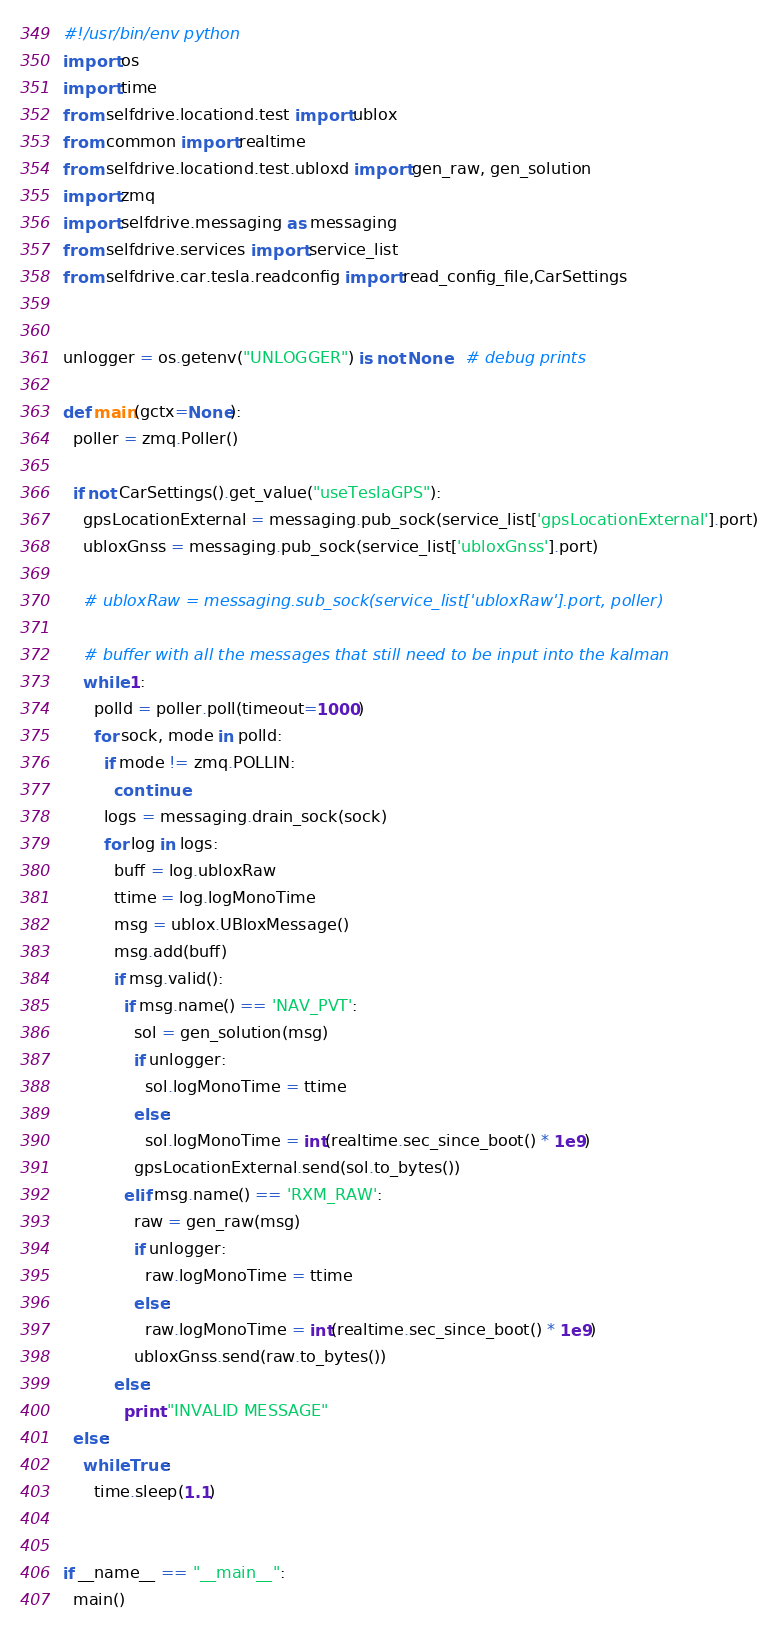<code> <loc_0><loc_0><loc_500><loc_500><_Python_>#!/usr/bin/env python
import os
import time
from selfdrive.locationd.test import ublox
from common import realtime
from selfdrive.locationd.test.ubloxd import gen_raw, gen_solution
import zmq
import selfdrive.messaging as messaging
from selfdrive.services import service_list
from selfdrive.car.tesla.readconfig import read_config_file,CarSettings


unlogger = os.getenv("UNLOGGER") is not None   # debug prints

def main(gctx=None):
  poller = zmq.Poller()

  if not CarSettings().get_value("useTeslaGPS"):
    gpsLocationExternal = messaging.pub_sock(service_list['gpsLocationExternal'].port)
    ubloxGnss = messaging.pub_sock(service_list['ubloxGnss'].port)

    # ubloxRaw = messaging.sub_sock(service_list['ubloxRaw'].port, poller)

    # buffer with all the messages that still need to be input into the kalman
    while 1:
      polld = poller.poll(timeout=1000)
      for sock, mode in polld:
        if mode != zmq.POLLIN:
          continue
        logs = messaging.drain_sock(sock)
        for log in logs:
          buff = log.ubloxRaw
          ttime = log.logMonoTime
          msg = ublox.UBloxMessage()
          msg.add(buff)
          if msg.valid():
            if msg.name() == 'NAV_PVT':
              sol = gen_solution(msg)
              if unlogger:
                sol.logMonoTime = ttime
              else:
                sol.logMonoTime = int(realtime.sec_since_boot() * 1e9)
              gpsLocationExternal.send(sol.to_bytes())
            elif msg.name() == 'RXM_RAW':
              raw = gen_raw(msg)
              if unlogger:
                raw.logMonoTime = ttime
              else:
                raw.logMonoTime = int(realtime.sec_since_boot() * 1e9)
              ubloxGnss.send(raw.to_bytes())
          else:
            print "INVALID MESSAGE"
  else:
    while True:
      time.sleep(1.1)


if __name__ == "__main__":
  main()
</code> 